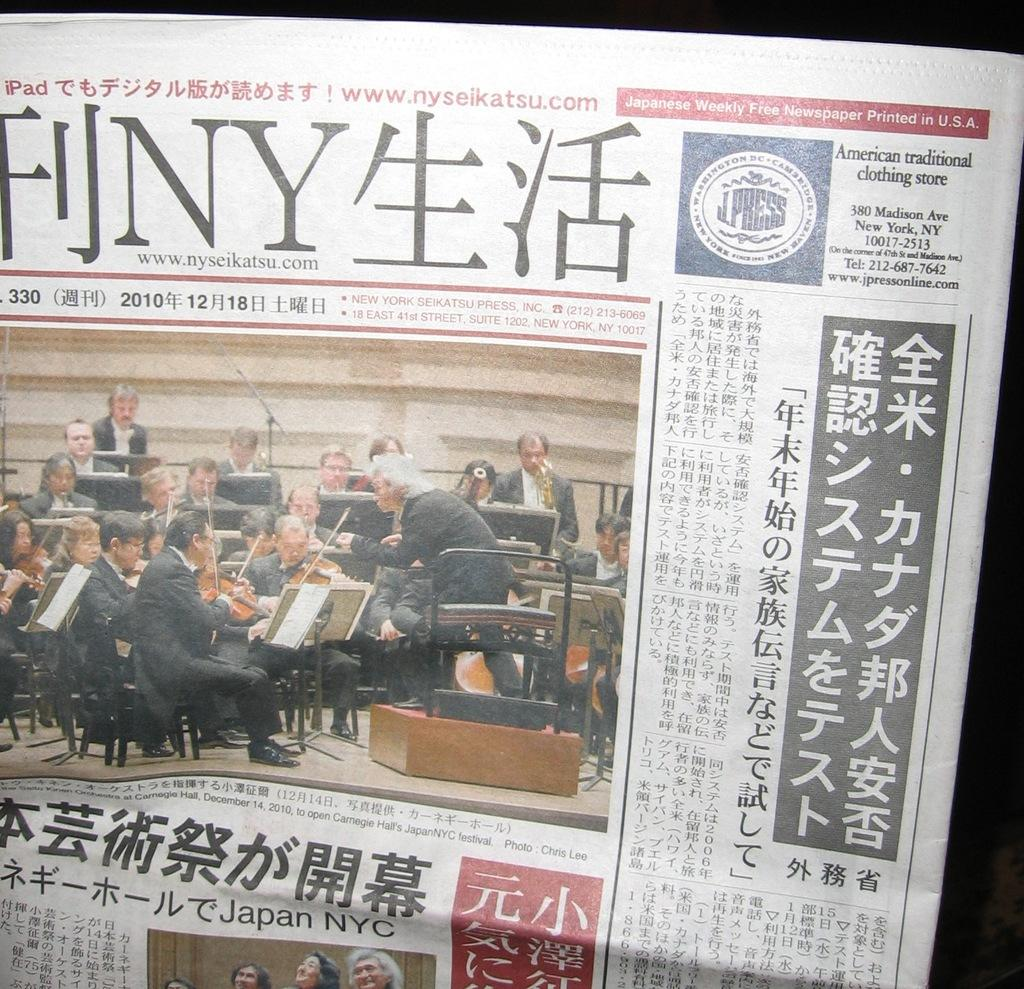What is written on the paper in the image? The provided facts do not specify the content of the text on the paper. How many people are in the image? There are people in the image, but the exact number is not mentioned in the provided facts. How many horses are visible in the image? There are no horses present in the image. What type of sign is hanging on the wall in the image? The provided facts do not mention any signs in the image. 